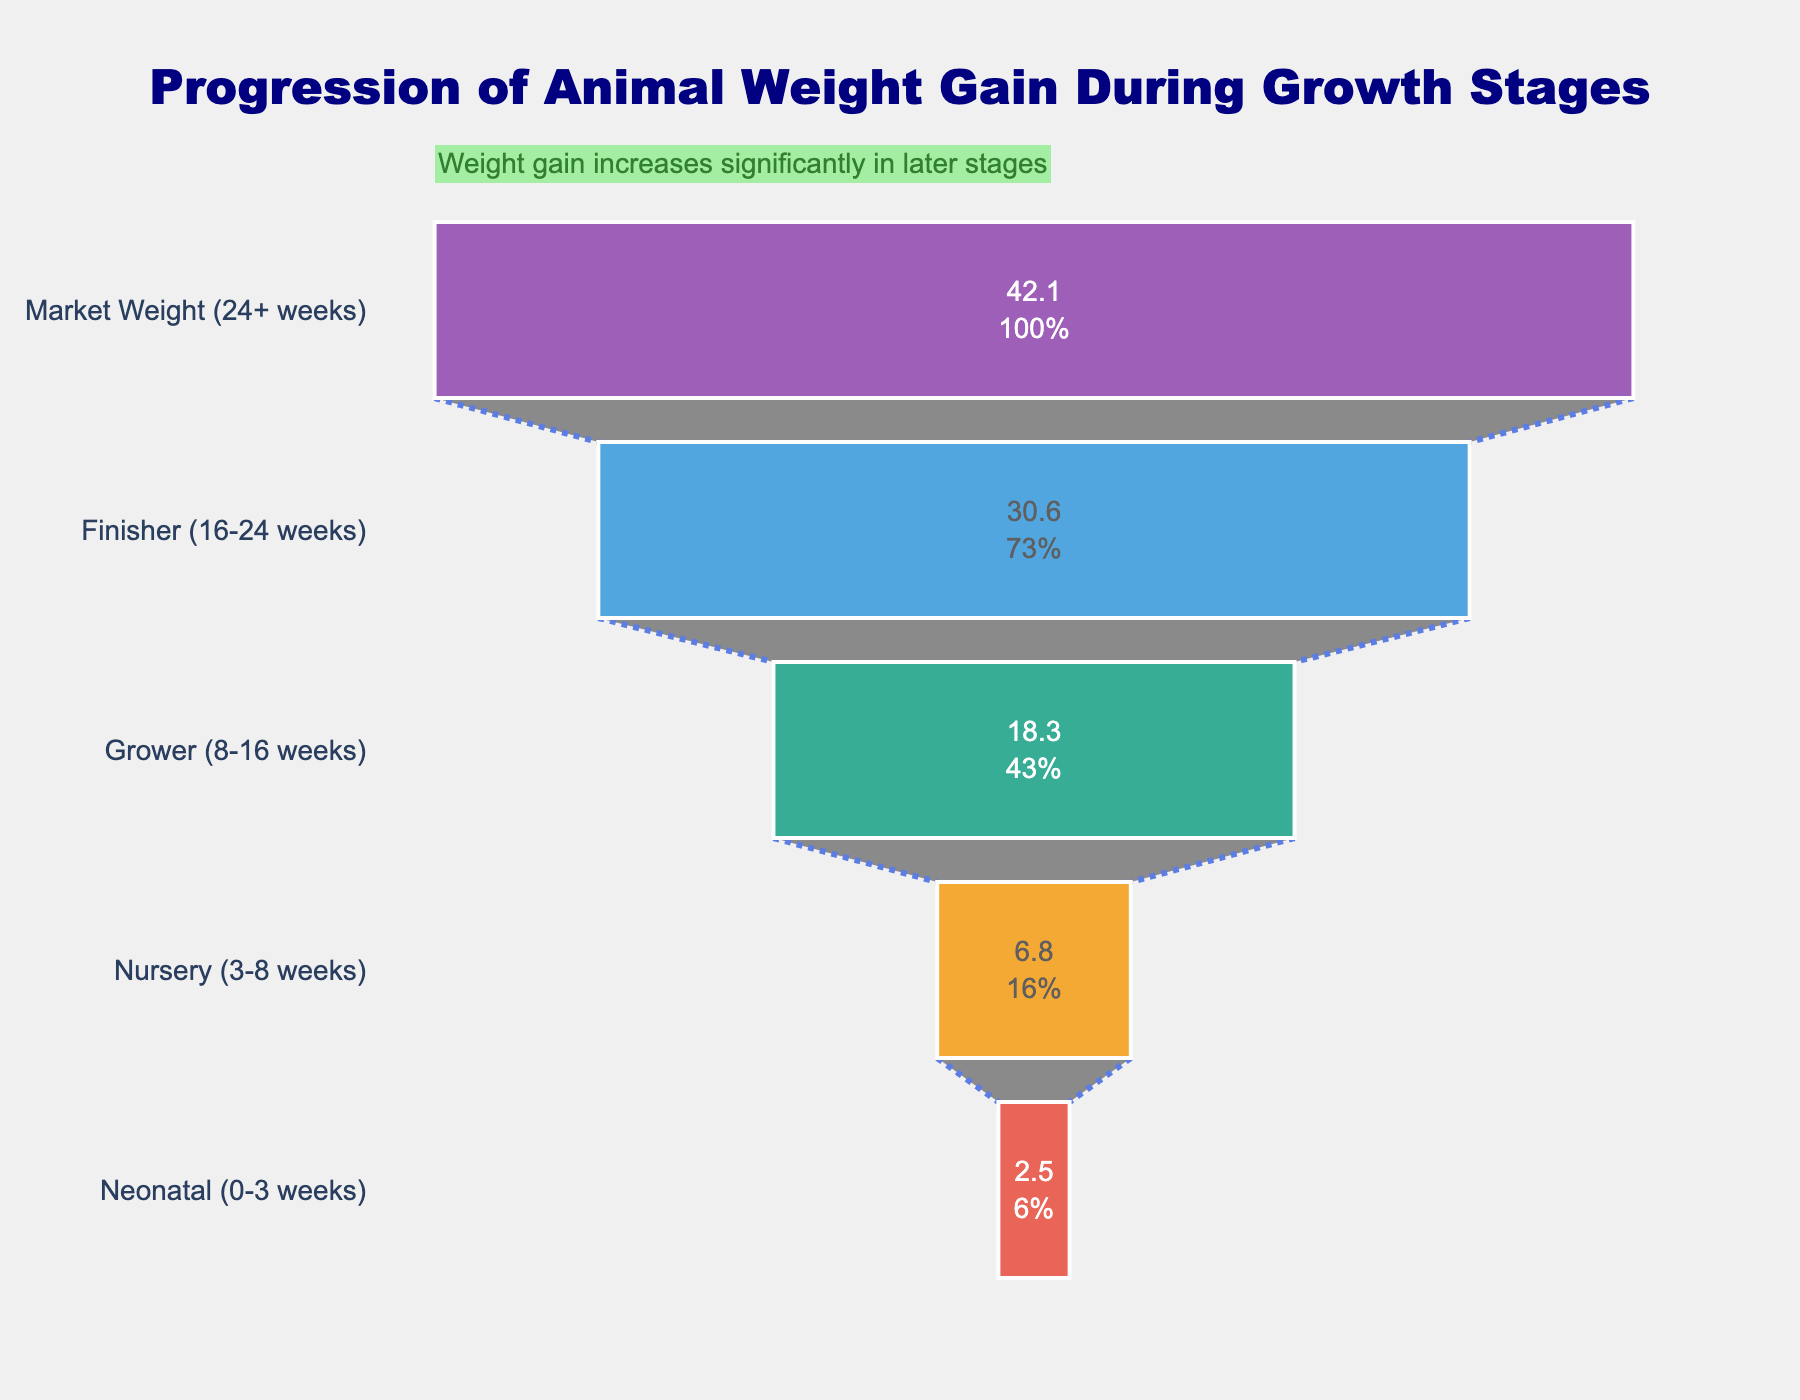What is the title of the figure? The title is usually displayed clearly at the top of the figure. Here, it reads "Progression of Animal Weight Gain During Growth Stages".
Answer: Progression of Animal Weight Gain During Growth Stages What are the five growth stages mentioned in the funnel chart? They are listed on the y-axis of the funnel chart in descending order of weight gain: Market Weight (24+ weeks), Finisher (16-24 weeks), Grower (8-16 weeks), Nursery (3-8 weeks), and Neonatal (0-3 weeks).
Answer: Market Weight (24+ weeks), Finisher (16-24 weeks), Grower (8-16 weeks), Nursery (3-8 weeks), Neonatal (0-3 weeks) Which growth stage has the highest weight gain? The stage with the highest bar length at the top of the funnel chart indicates the highest weight gain, which is "Market Weight (24+ weeks)".
Answer: Market Weight (24+ weeks) What is the weight gain for the Finisher stage? Refer to the segment labeled "Finisher (16-24 weeks)" on the funnel chart, the weight gain displayed is 30.6 kg.
Answer: 30.6 kg How much total weight gain occurs from the Nursery stage to the Market Weight stage? Identify and sum the weight gains for "Nursery," "Grower," "Finisher," and "Market Weight" stages: 6.8 kg + 18.3 kg + 30.6 kg + 42.1 kg.
Answer: 97.8 kg Which stage shows a weight gain closest to 20 kg? Locate the stage segments on the funnel chart and find the one with the weight gain closest to 20 kg, which is "Grower (8-16 weeks)" with 18.3 kg.
Answer: Grower (8-16 weeks) How much more do animals gain in the Grower stage compared to the Nursery stage? Subtract the Nursery stage weight gain from the Grower stage weight gain: 18.3 kg - 6.8 kg.
Answer: 11.5 kg What percentage of the initial total weight gain does the Neonatal stage represent? The total initial weight gain (weight gain at the Market stage) is 42.1 kg. Divide the Neonatal weight gain by this total and multiply by 100 to get the percentage: (2.5/42.1) * 100.
Answer: 5.94% Which two consecutive stages have the largest increase in weight gain? Compare the differences between consecutive stages: Neonatal to Nursery, Nursery to Grower, Grower to Finisher, and Finisher to Market Weight. Identify the pair with the largest increase: Grower to Finisher (18.3 kg to 30.6 kg) = 12.3 kg.
Answer: Grower to Finisher (12.3 kg) What does the annotation at the top of the funnel chart indicate? The annotation presents a qualitative insight saying, "Weight gain increases significantly in later stages", highlighting that weight gain accelerates especially in later growth stages.
Answer: Weight gain increases significantly in later stages 